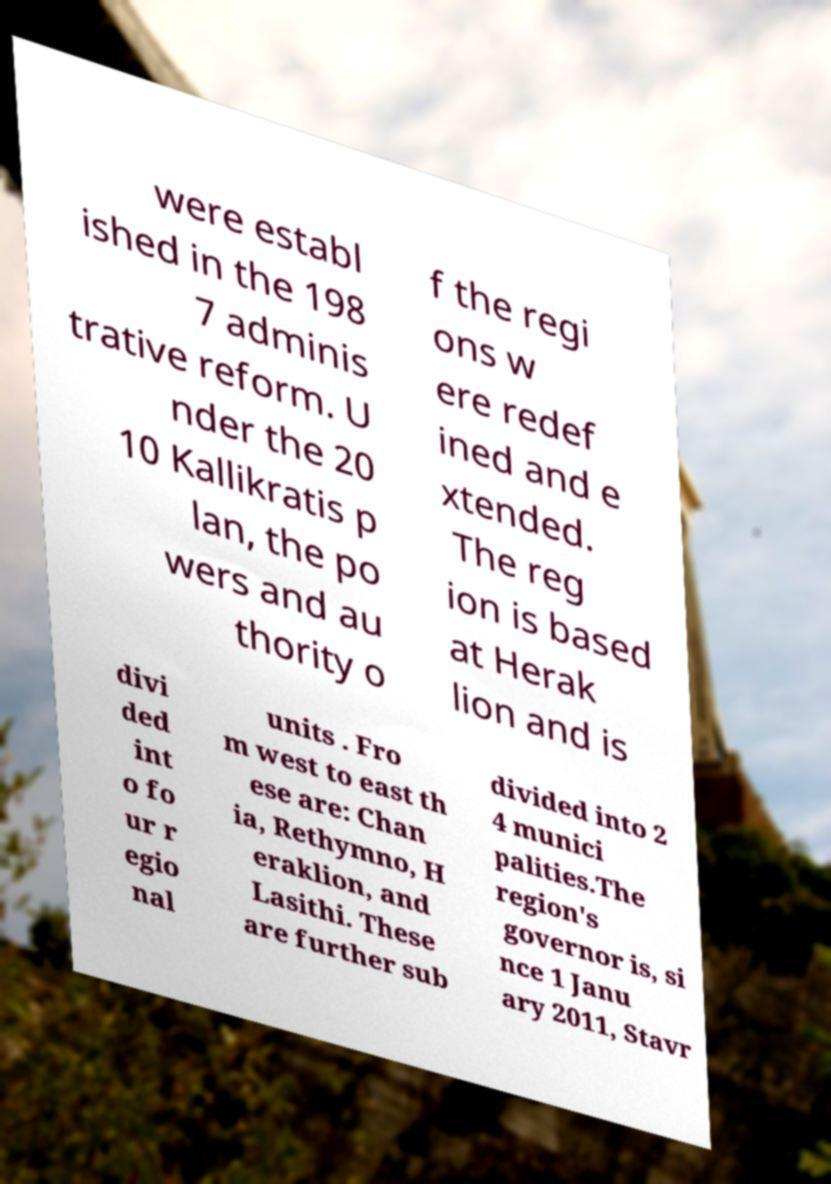Could you extract and type out the text from this image? were establ ished in the 198 7 adminis trative reform. U nder the 20 10 Kallikratis p lan, the po wers and au thority o f the regi ons w ere redef ined and e xtended. The reg ion is based at Herak lion and is divi ded int o fo ur r egio nal units . Fro m west to east th ese are: Chan ia, Rethymno, H eraklion, and Lasithi. These are further sub divided into 2 4 munici palities.The region's governor is, si nce 1 Janu ary 2011, Stavr 